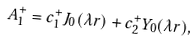<formula> <loc_0><loc_0><loc_500><loc_500>A _ { 1 } ^ { + } = c ^ { + } _ { 1 } J _ { 0 } ( \lambda r ) + c ^ { + } _ { 2 } Y _ { 0 } ( \lambda r ) ,</formula> 